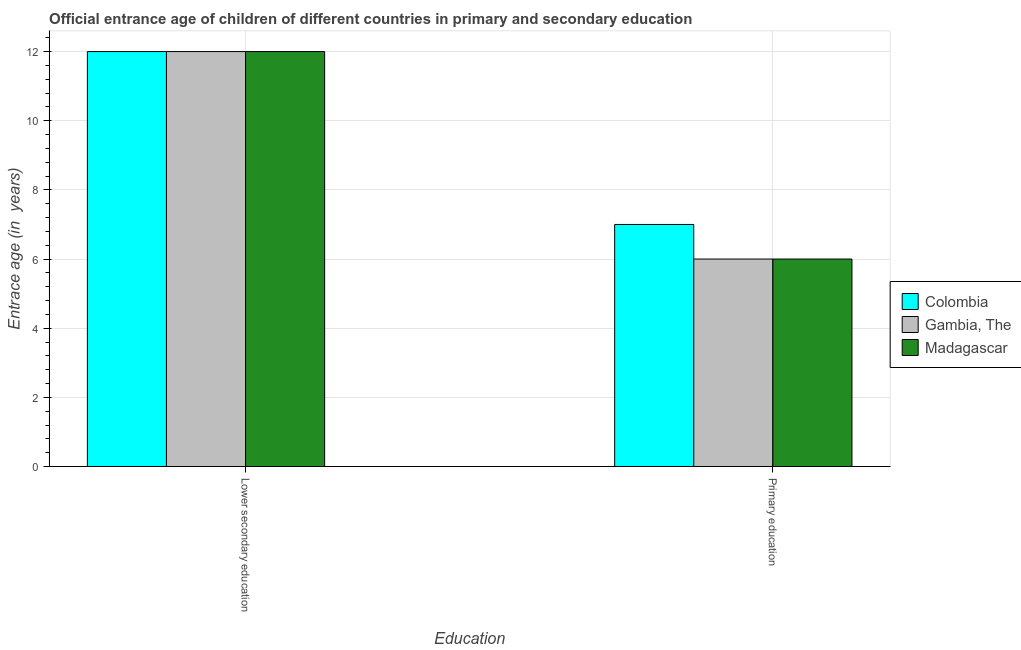Are the number of bars per tick equal to the number of legend labels?
Offer a terse response. Yes. Are the number of bars on each tick of the X-axis equal?
Keep it short and to the point. Yes. Across all countries, what is the maximum entrance age of children in lower secondary education?
Provide a short and direct response. 12. In which country was the entrance age of chiildren in primary education minimum?
Offer a very short reply. Gambia, The. What is the total entrance age of chiildren in primary education in the graph?
Your answer should be very brief. 19. What is the difference between the entrance age of chiildren in primary education in Colombia and that in Madagascar?
Make the answer very short. 1. What is the difference between the entrance age of children in lower secondary education in Madagascar and the entrance age of chiildren in primary education in Colombia?
Keep it short and to the point. 5. What is the difference between the entrance age of chiildren in primary education and entrance age of children in lower secondary education in Colombia?
Offer a very short reply. -5. What is the ratio of the entrance age of chiildren in primary education in Gambia, The to that in Madagascar?
Provide a succinct answer. 1. In how many countries, is the entrance age of children in lower secondary education greater than the average entrance age of children in lower secondary education taken over all countries?
Offer a very short reply. 0. What does the 1st bar from the left in Lower secondary education represents?
Make the answer very short. Colombia. What does the 1st bar from the right in Lower secondary education represents?
Offer a terse response. Madagascar. How many bars are there?
Make the answer very short. 6. Are all the bars in the graph horizontal?
Keep it short and to the point. No. Does the graph contain any zero values?
Make the answer very short. No. Does the graph contain grids?
Your answer should be very brief. Yes. How many legend labels are there?
Provide a succinct answer. 3. How are the legend labels stacked?
Offer a terse response. Vertical. What is the title of the graph?
Offer a very short reply. Official entrance age of children of different countries in primary and secondary education. Does "Congo (Republic)" appear as one of the legend labels in the graph?
Offer a very short reply. No. What is the label or title of the X-axis?
Your answer should be very brief. Education. What is the label or title of the Y-axis?
Provide a short and direct response. Entrace age (in  years). What is the Entrace age (in  years) of Colombia in Lower secondary education?
Offer a terse response. 12. What is the Entrace age (in  years) of Gambia, The in Lower secondary education?
Your answer should be very brief. 12. What is the Entrace age (in  years) of Madagascar in Lower secondary education?
Provide a short and direct response. 12. What is the Entrace age (in  years) in Colombia in Primary education?
Your answer should be very brief. 7. What is the Entrace age (in  years) in Gambia, The in Primary education?
Offer a very short reply. 6. What is the Entrace age (in  years) of Madagascar in Primary education?
Your answer should be compact. 6. Across all Education, what is the maximum Entrace age (in  years) in Colombia?
Keep it short and to the point. 12. Across all Education, what is the maximum Entrace age (in  years) in Gambia, The?
Offer a terse response. 12. What is the total Entrace age (in  years) in Gambia, The in the graph?
Your response must be concise. 18. What is the total Entrace age (in  years) of Madagascar in the graph?
Keep it short and to the point. 18. What is the difference between the Entrace age (in  years) in Colombia in Lower secondary education and that in Primary education?
Offer a terse response. 5. What is the difference between the Entrace age (in  years) in Madagascar in Lower secondary education and that in Primary education?
Your answer should be very brief. 6. What is the difference between the Entrace age (in  years) in Colombia in Lower secondary education and the Entrace age (in  years) in Gambia, The in Primary education?
Provide a short and direct response. 6. What is the difference between the Entrace age (in  years) in Colombia and Entrace age (in  years) in Gambia, The in Lower secondary education?
Offer a very short reply. 0. What is the difference between the Entrace age (in  years) in Colombia and Entrace age (in  years) in Gambia, The in Primary education?
Make the answer very short. 1. What is the difference between the Entrace age (in  years) in Gambia, The and Entrace age (in  years) in Madagascar in Primary education?
Make the answer very short. 0. What is the ratio of the Entrace age (in  years) of Colombia in Lower secondary education to that in Primary education?
Keep it short and to the point. 1.71. What is the ratio of the Entrace age (in  years) of Gambia, The in Lower secondary education to that in Primary education?
Keep it short and to the point. 2. What is the difference between the highest and the second highest Entrace age (in  years) of Colombia?
Your answer should be very brief. 5. What is the difference between the highest and the second highest Entrace age (in  years) of Madagascar?
Your answer should be compact. 6. What is the difference between the highest and the lowest Entrace age (in  years) of Colombia?
Give a very brief answer. 5. What is the difference between the highest and the lowest Entrace age (in  years) in Madagascar?
Your answer should be compact. 6. 